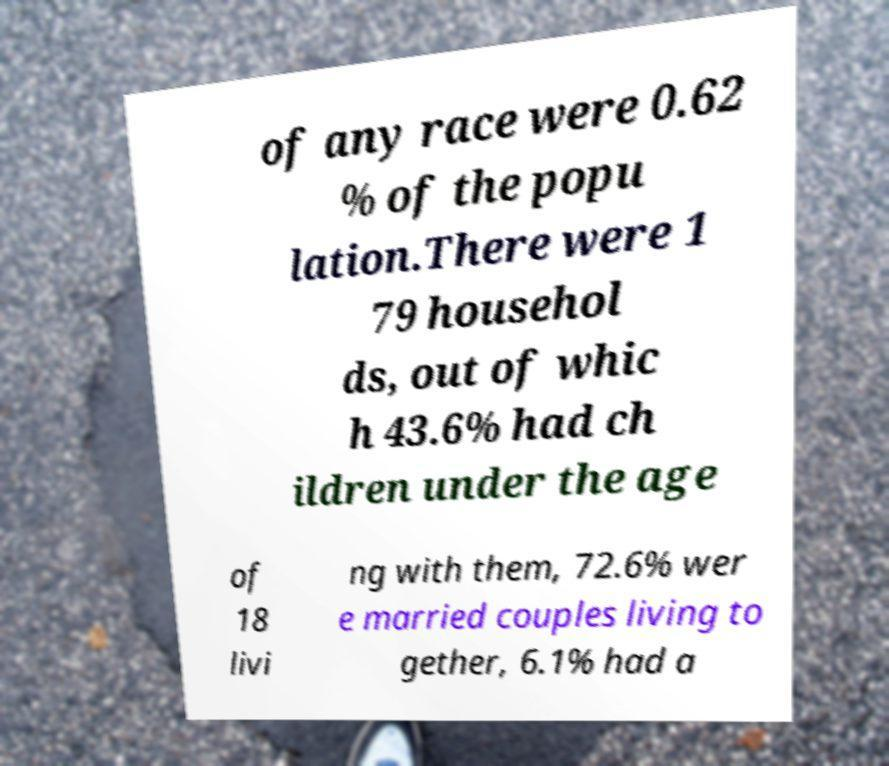Can you accurately transcribe the text from the provided image for me? of any race were 0.62 % of the popu lation.There were 1 79 househol ds, out of whic h 43.6% had ch ildren under the age of 18 livi ng with them, 72.6% wer e married couples living to gether, 6.1% had a 